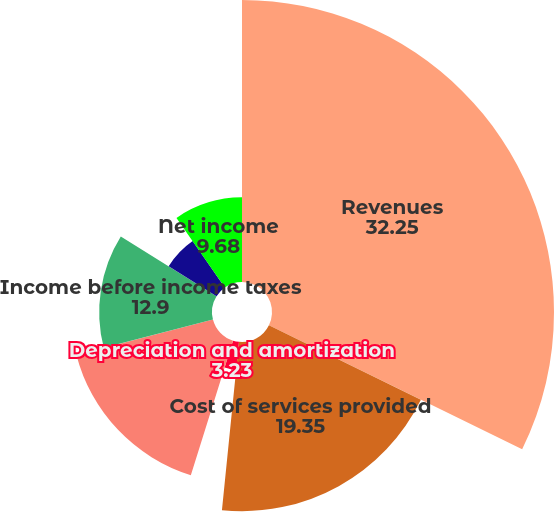<chart> <loc_0><loc_0><loc_500><loc_500><pie_chart><fcel>Revenues<fcel>Cost of services provided<fcel>Depreciation and amortization<fcel>Sales general and<fcel>(Gain)/loss on<fcel>Income before income taxes<fcel>Provision for income taxes<fcel>Net income<nl><fcel>32.25%<fcel>19.35%<fcel>3.23%<fcel>16.13%<fcel>0.0%<fcel>12.9%<fcel>6.45%<fcel>9.68%<nl></chart> 